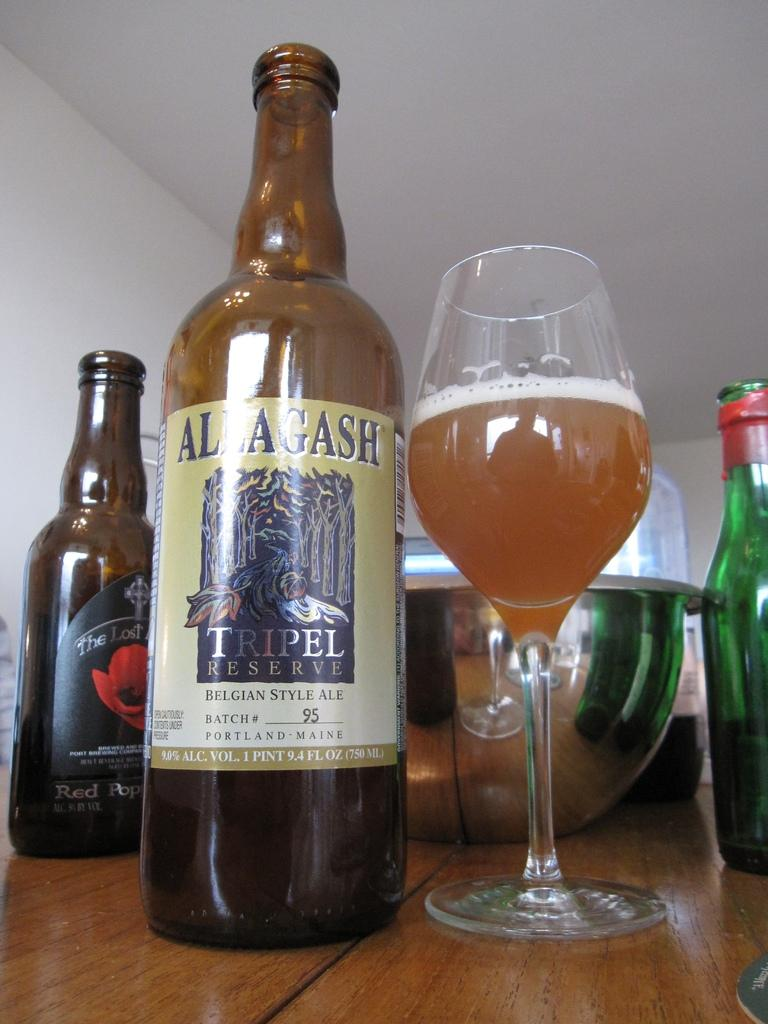<image>
Describe the image concisely. A bottle of Allagash ale sits next to a stemmed glass of beer. 